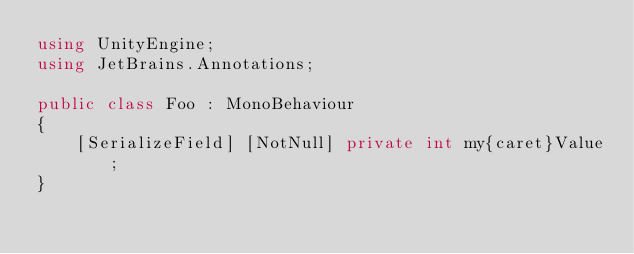<code> <loc_0><loc_0><loc_500><loc_500><_C#_>using UnityEngine;
using JetBrains.Annotations;

public class Foo : MonoBehaviour
{
    [SerializeField] [NotNull] private int my{caret}Value;
}
</code> 